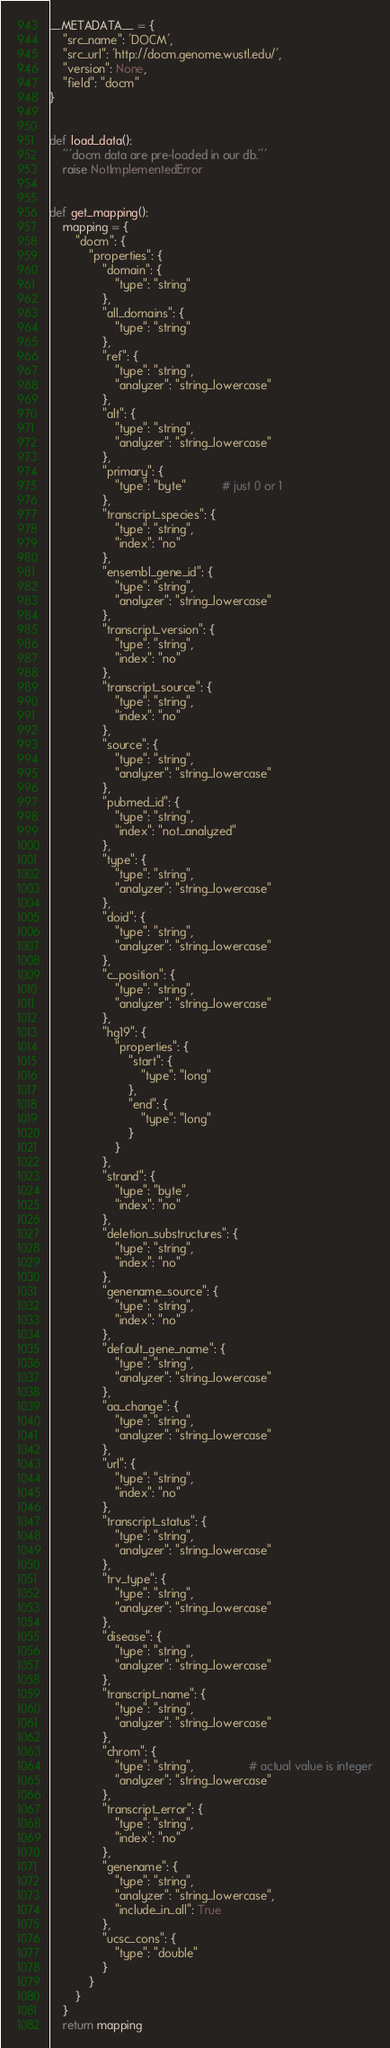<code> <loc_0><loc_0><loc_500><loc_500><_Python_>__METADATA__ = {
    "src_name": 'DOCM',
    "src_url": 'http://docm.genome.wustl.edu/',
    "version": None,
    "field": "docm"
}


def load_data():
    '''docm data are pre-loaded in our db.'''
    raise NotImplementedError


def get_mapping():
    mapping = {
        "docm": {
            "properties": {
                "domain": {
                    "type": "string"
                },
                "all_domains": {
                    "type": "string"
                },
                "ref": {
                    "type": "string",
                    "analyzer": "string_lowercase"
                },
                "alt": {
                    "type": "string",
                    "analyzer": "string_lowercase"
                },
                "primary": {
                    "type": "byte"           # just 0 or 1
                },
                "transcript_species": {
                    "type": "string",
                    "index": "no"
                },
                "ensembl_gene_id": {
                    "type": "string",
                    "analyzer": "string_lowercase"
                },
                "transcript_version": {
                    "type": "string",
                    "index": "no"
                },
                "transcript_source": {
                    "type": "string",
                    "index": "no"
                },
                "source": {
                    "type": "string",
                    "analyzer": "string_lowercase"
                },
                "pubmed_id": {
                    "type": "string",
                    "index": "not_analyzed"
                },
                "type": {
                    "type": "string",
                    "analyzer": "string_lowercase"
                },
                "doid": {
                    "type": "string",
                    "analyzer": "string_lowercase"
                },
                "c_position": {
                    "type": "string",
                    "analyzer": "string_lowercase"
                },
                "hg19": {
                    "properties": {
                        "start": {
                            "type": "long"
                        },
                        "end": {
                            "type": "long"
                        }
                    }
                },
                "strand": {
                    "type": "byte",
                    "index": "no"
                },
                "deletion_substructures": {
                    "type": "string",
                    "index": "no"
                },
                "genename_source": {
                    "type": "string",
                    "index": "no"
                },
                "default_gene_name": {
                    "type": "string",
                    "analyzer": "string_lowercase"
                },
                "aa_change": {
                    "type": "string",
                    "analyzer": "string_lowercase"
                },
                "url": {
                    "type": "string",
                    "index": "no"
                },
                "transcript_status": {
                    "type": "string",
                    "analyzer": "string_lowercase"
                },
                "trv_type": {
                    "type": "string",
                    "analyzer": "string_lowercase"
                },
                "disease": {
                    "type": "string",
                    "analyzer": "string_lowercase"
                },
                "transcript_name": {
                    "type": "string",
                    "analyzer": "string_lowercase"
                },
                "chrom": {
                    "type": "string",                 # actual value is integer
                    "analyzer": "string_lowercase"
                },
                "transcript_error": {
                    "type": "string",
                    "index": "no"
                },
                "genename": {
                    "type": "string",
                    "analyzer": "string_lowercase",
                    "include_in_all": True
                },
                "ucsc_cons": {
                    "type": "double"
                }
            }
        }
    }
    return mapping
</code> 